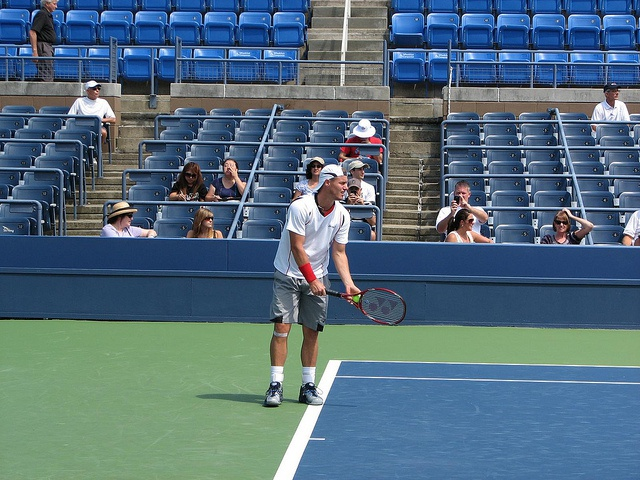Describe the objects in this image and their specific colors. I can see chair in blue, navy, and gray tones, people in blue, white, darkgray, gray, and black tones, chair in blue, navy, lightblue, and gray tones, people in blue, white, black, gray, and maroon tones, and people in blue, black, gray, navy, and brown tones in this image. 